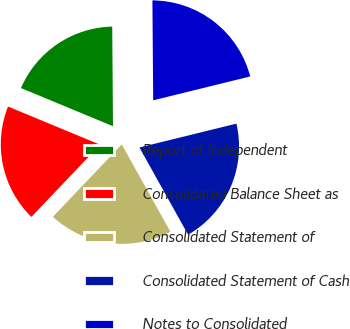<chart> <loc_0><loc_0><loc_500><loc_500><pie_chart><fcel>Report of Independent<fcel>Consolidated Balance Sheet as<fcel>Consolidated Statement of<fcel>Consolidated Statement of Cash<fcel>Notes to Consolidated<nl><fcel>18.62%<fcel>19.15%<fcel>20.21%<fcel>20.74%<fcel>21.28%<nl></chart> 